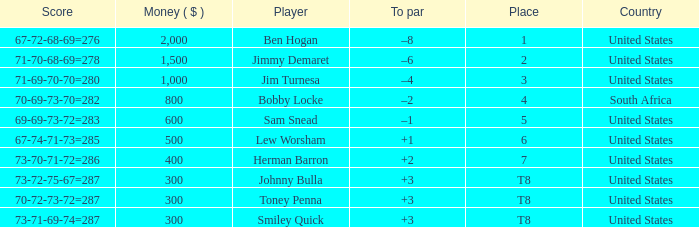What is the Place of the Player with a To par of –1? 5.0. 